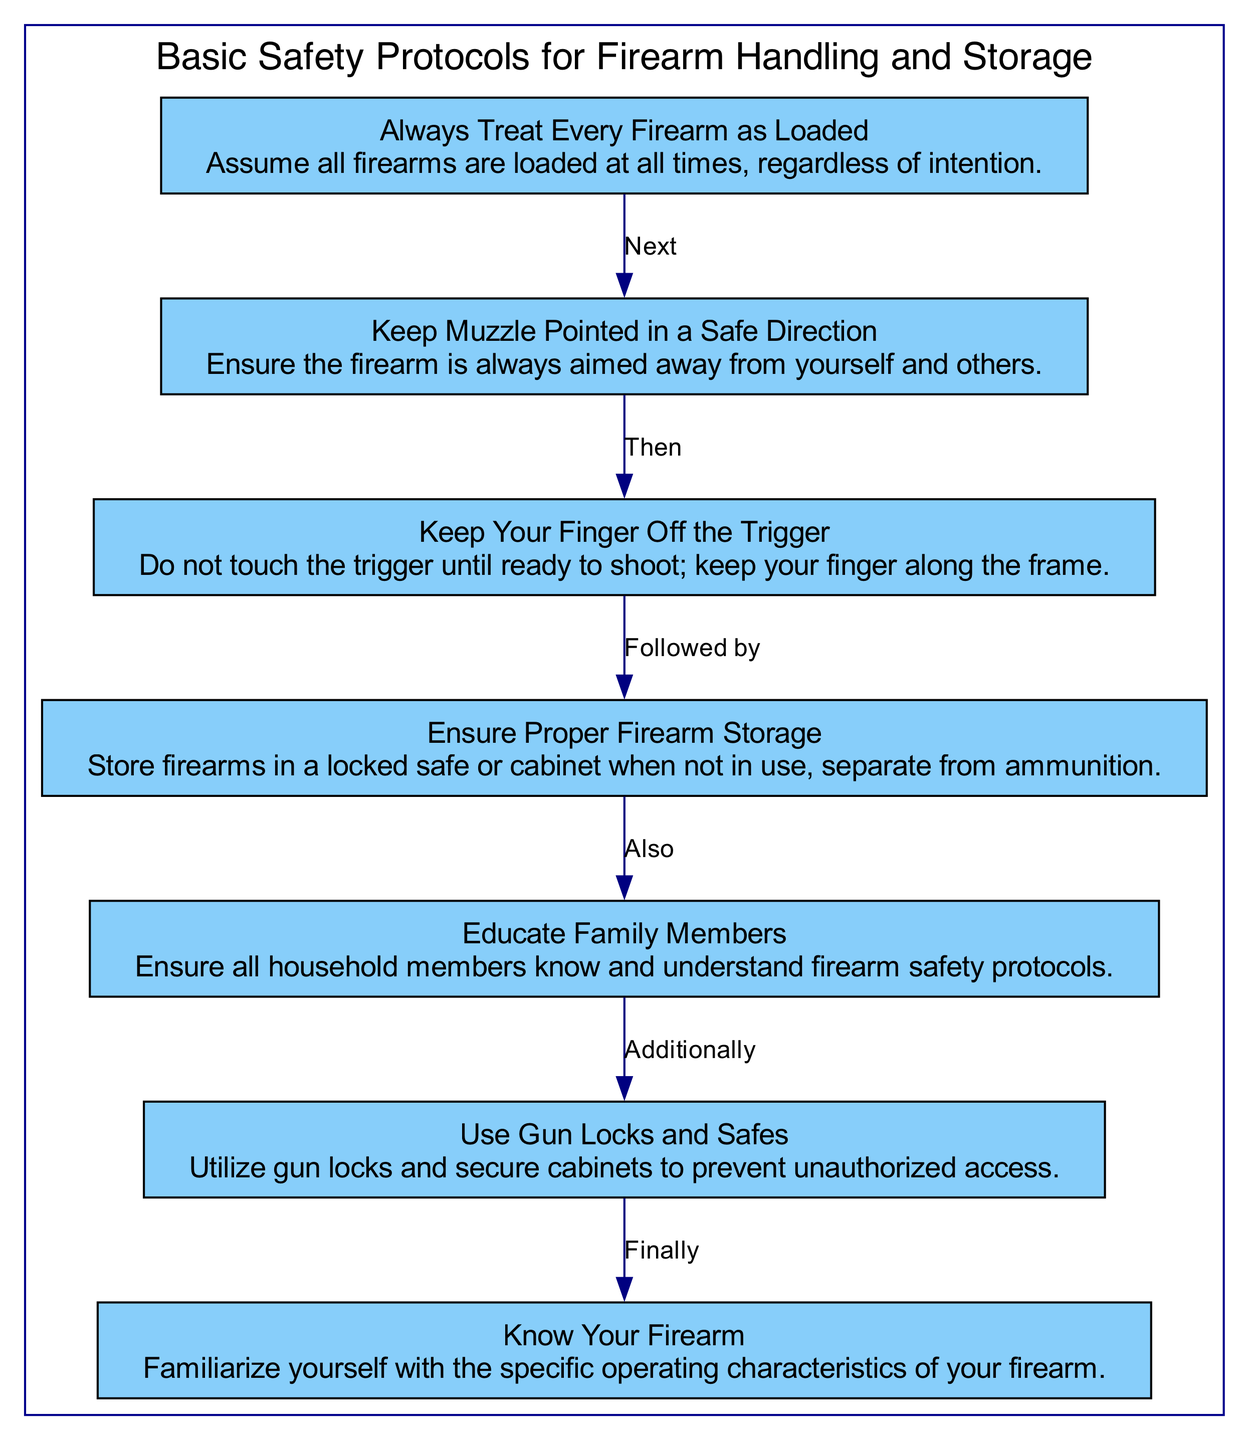What is the first step in firearm safety? The diagram shows that the first step is to always treat every firearm as loaded. This is indicated by the node labeled 'Always Treat Every Firearm as Loaded', which is at the top of the flow chart.
Answer: Always Treat Every Firearm as Loaded How many steps are there in total for firearm safety? By counting the number of nodes in the flowchart, we find there are seven distinct steps that outline the basic safety protocols for firearm handling and storage.
Answer: 7 What follows after keeping the muzzle pointed in a safe direction? According to the diagram, the step that comes after keeping the muzzle pointed in a safe direction is keeping your finger off the trigger. This is indicated by the flow from node '2' to node '3'.
Answer: Keep Your Finger Off the Trigger What is the last protocol mentioned in the flow chart? The diagram concludes with the step of knowing your firearm, which is the last node in the flow sequence. It is connected from the sixth step about using gun locks and safes.
Answer: Know Your Firearm What additional safety measure is highlighted after ensuring proper firearm storage? The flow chart highlights the need to educate family members as an additional safety measure that follows ensuring proper firearm storage. This is shown by the edge connecting node '4' to node '5'.
Answer: Educate Family Members What should be done to prevent unauthorized access to firearms? The diagram indicates that using gun locks and safes is essential to prevent unauthorized access to firearms. This is present in the step that connects from educating family members to the use of gun locks.
Answer: Use Gun Locks and Safes 